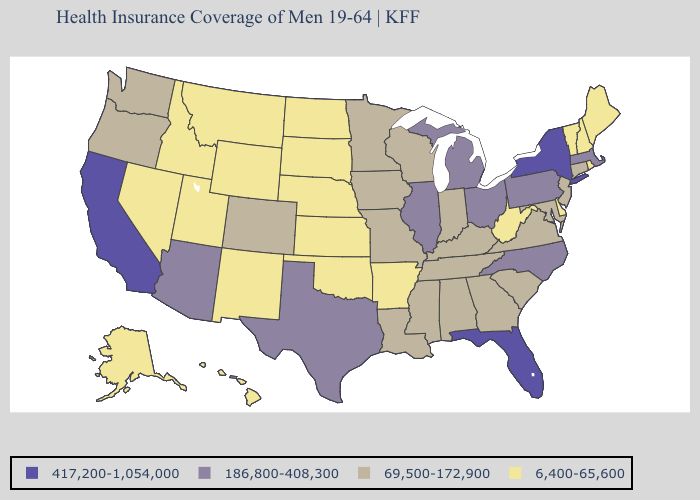Name the states that have a value in the range 417,200-1,054,000?
Quick response, please. California, Florida, New York. Among the states that border Tennessee , does North Carolina have the highest value?
Give a very brief answer. Yes. Name the states that have a value in the range 6,400-65,600?
Write a very short answer. Alaska, Arkansas, Delaware, Hawaii, Idaho, Kansas, Maine, Montana, Nebraska, Nevada, New Hampshire, New Mexico, North Dakota, Oklahoma, Rhode Island, South Dakota, Utah, Vermont, West Virginia, Wyoming. What is the highest value in states that border Kansas?
Short answer required. 69,500-172,900. Among the states that border Indiana , which have the lowest value?
Concise answer only. Kentucky. Name the states that have a value in the range 186,800-408,300?
Write a very short answer. Arizona, Illinois, Massachusetts, Michigan, North Carolina, Ohio, Pennsylvania, Texas. What is the lowest value in the Northeast?
Be succinct. 6,400-65,600. What is the value of Rhode Island?
Give a very brief answer. 6,400-65,600. Does the first symbol in the legend represent the smallest category?
Give a very brief answer. No. What is the value of New York?
Write a very short answer. 417,200-1,054,000. Which states hav the highest value in the West?
Give a very brief answer. California. What is the value of Kentucky?
Give a very brief answer. 69,500-172,900. Which states have the highest value in the USA?
Keep it brief. California, Florida, New York. What is the value of North Carolina?
Quick response, please. 186,800-408,300. What is the lowest value in the Northeast?
Concise answer only. 6,400-65,600. 